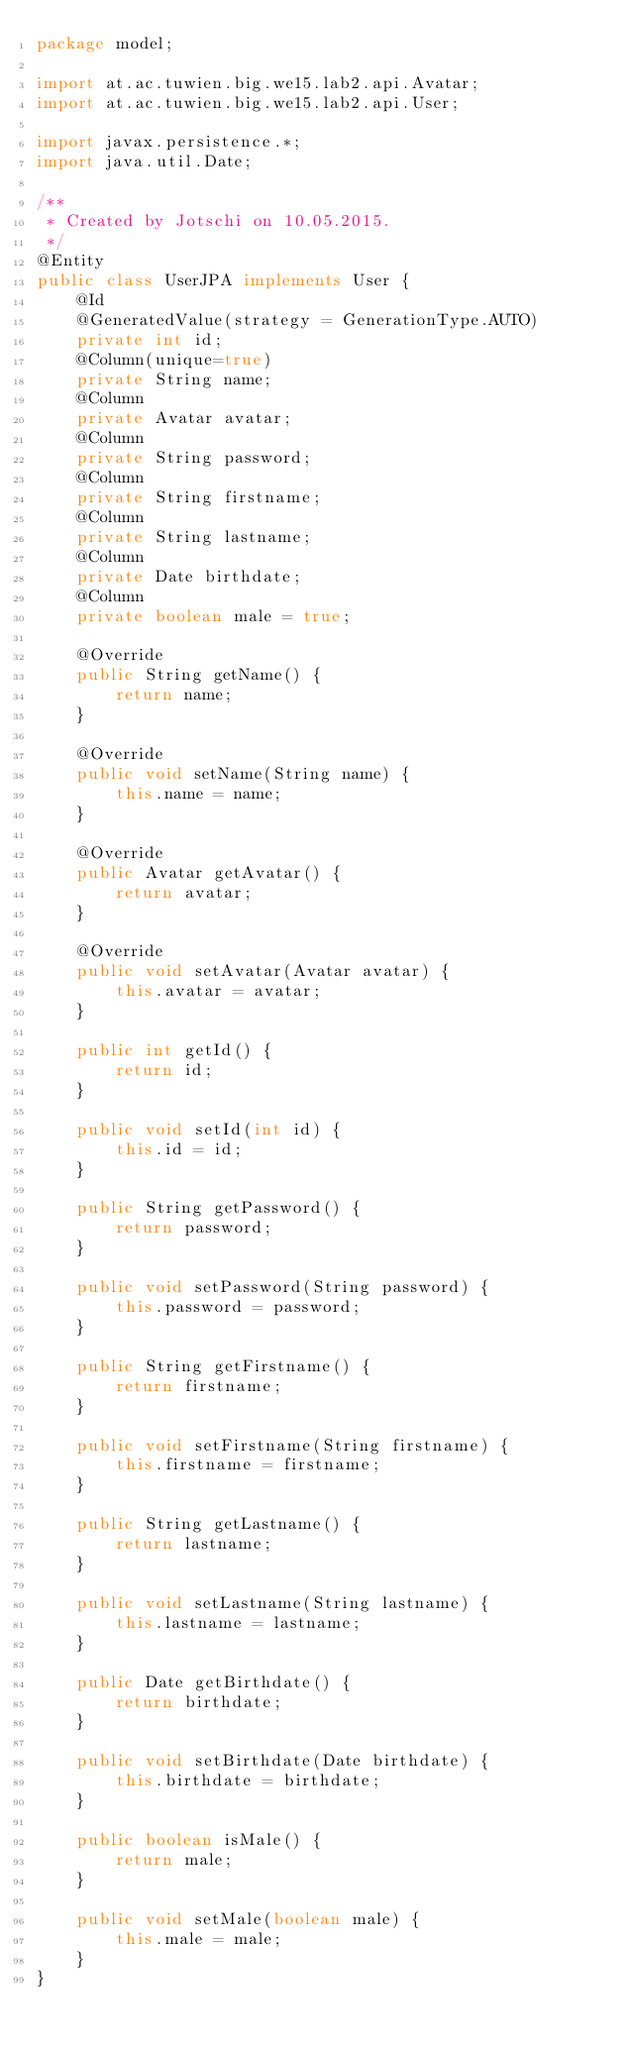<code> <loc_0><loc_0><loc_500><loc_500><_Java_>package model;

import at.ac.tuwien.big.we15.lab2.api.Avatar;
import at.ac.tuwien.big.we15.lab2.api.User;

import javax.persistence.*;
import java.util.Date;

/**
 * Created by Jotschi on 10.05.2015.
 */
@Entity
public class UserJPA implements User {
    @Id
    @GeneratedValue(strategy = GenerationType.AUTO)
    private int id;
    @Column(unique=true)
    private String name;
    @Column
    private Avatar avatar;
    @Column
    private String password;
    @Column
    private String firstname;
    @Column
    private String lastname;
    @Column
    private Date birthdate;
    @Column
    private boolean male = true;

    @Override
    public String getName() {
        return name;
    }

    @Override
    public void setName(String name) {
        this.name = name;
    }

    @Override
    public Avatar getAvatar() {
        return avatar;
    }

    @Override
    public void setAvatar(Avatar avatar) {
        this.avatar = avatar;
    }

    public int getId() {
        return id;
    }

    public void setId(int id) {
        this.id = id;
    }

    public String getPassword() {
        return password;
    }

    public void setPassword(String password) {
        this.password = password;
    }

    public String getFirstname() {
        return firstname;
    }

    public void setFirstname(String firstname) {
        this.firstname = firstname;
    }

    public String getLastname() {
        return lastname;
    }

    public void setLastname(String lastname) {
        this.lastname = lastname;
    }

    public Date getBirthdate() {
        return birthdate;
    }

    public void setBirthdate(Date birthdate) {
        this.birthdate = birthdate;
    }

    public boolean isMale() {
        return male;
    }

    public void setMale(boolean male) {
        this.male = male;
    }
}
</code> 